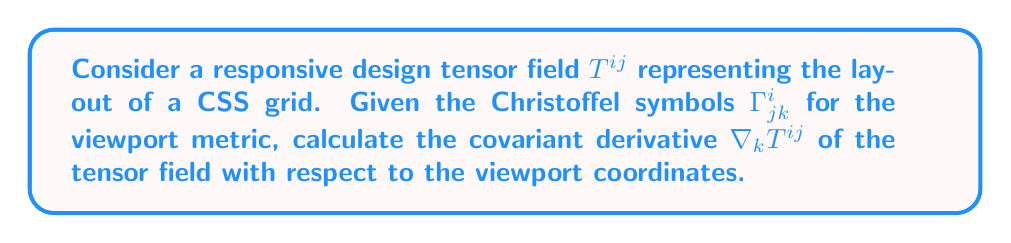Provide a solution to this math problem. To calculate the covariant derivative of the responsive design tensor field, we'll follow these steps:

1. Recall the formula for the covariant derivative of a contravariant tensor:

   $$\nabla_k T^{ij} = \partial_k T^{ij} + \Gamma^i_{lk} T^{lj} + \Gamma^j_{lk} T^{il}$$

2. Expand the partial derivative term:
   
   $$\partial_k T^{ij} = \frac{\partial T^{ij}}{\partial x^k}$$

3. Apply the Christoffel symbols to account for the curvature of the viewport:

   $$\Gamma^i_{lk} T^{lj} + \Gamma^j_{lk} T^{il}$$

4. Combine all terms:

   $$\nabla_k T^{ij} = \frac{\partial T^{ij}}{\partial x^k} + \Gamma^i_{lk} T^{lj} + \Gamma^j_{lk} T^{il}$$

This expression represents how the CSS grid layout tensor changes with respect to the viewport coordinates, taking into account the curvature of the responsive design space.
Answer: $$\nabla_k T^{ij} = \frac{\partial T^{ij}}{\partial x^k} + \Gamma^i_{lk} T^{lj} + \Gamma^j_{lk} T^{il}$$ 